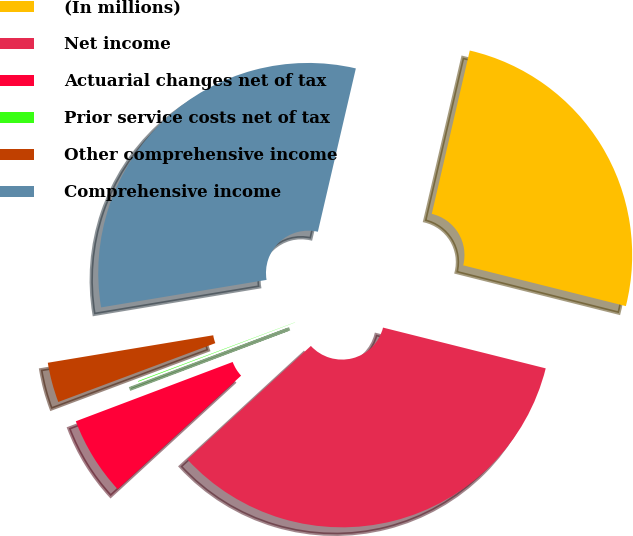<chart> <loc_0><loc_0><loc_500><loc_500><pie_chart><fcel>(In millions)<fcel>Net income<fcel>Actuarial changes net of tax<fcel>Prior service costs net of tax<fcel>Other comprehensive income<fcel>Comprehensive income<nl><fcel>25.27%<fcel>34.26%<fcel>6.08%<fcel>0.05%<fcel>3.08%<fcel>31.26%<nl></chart> 